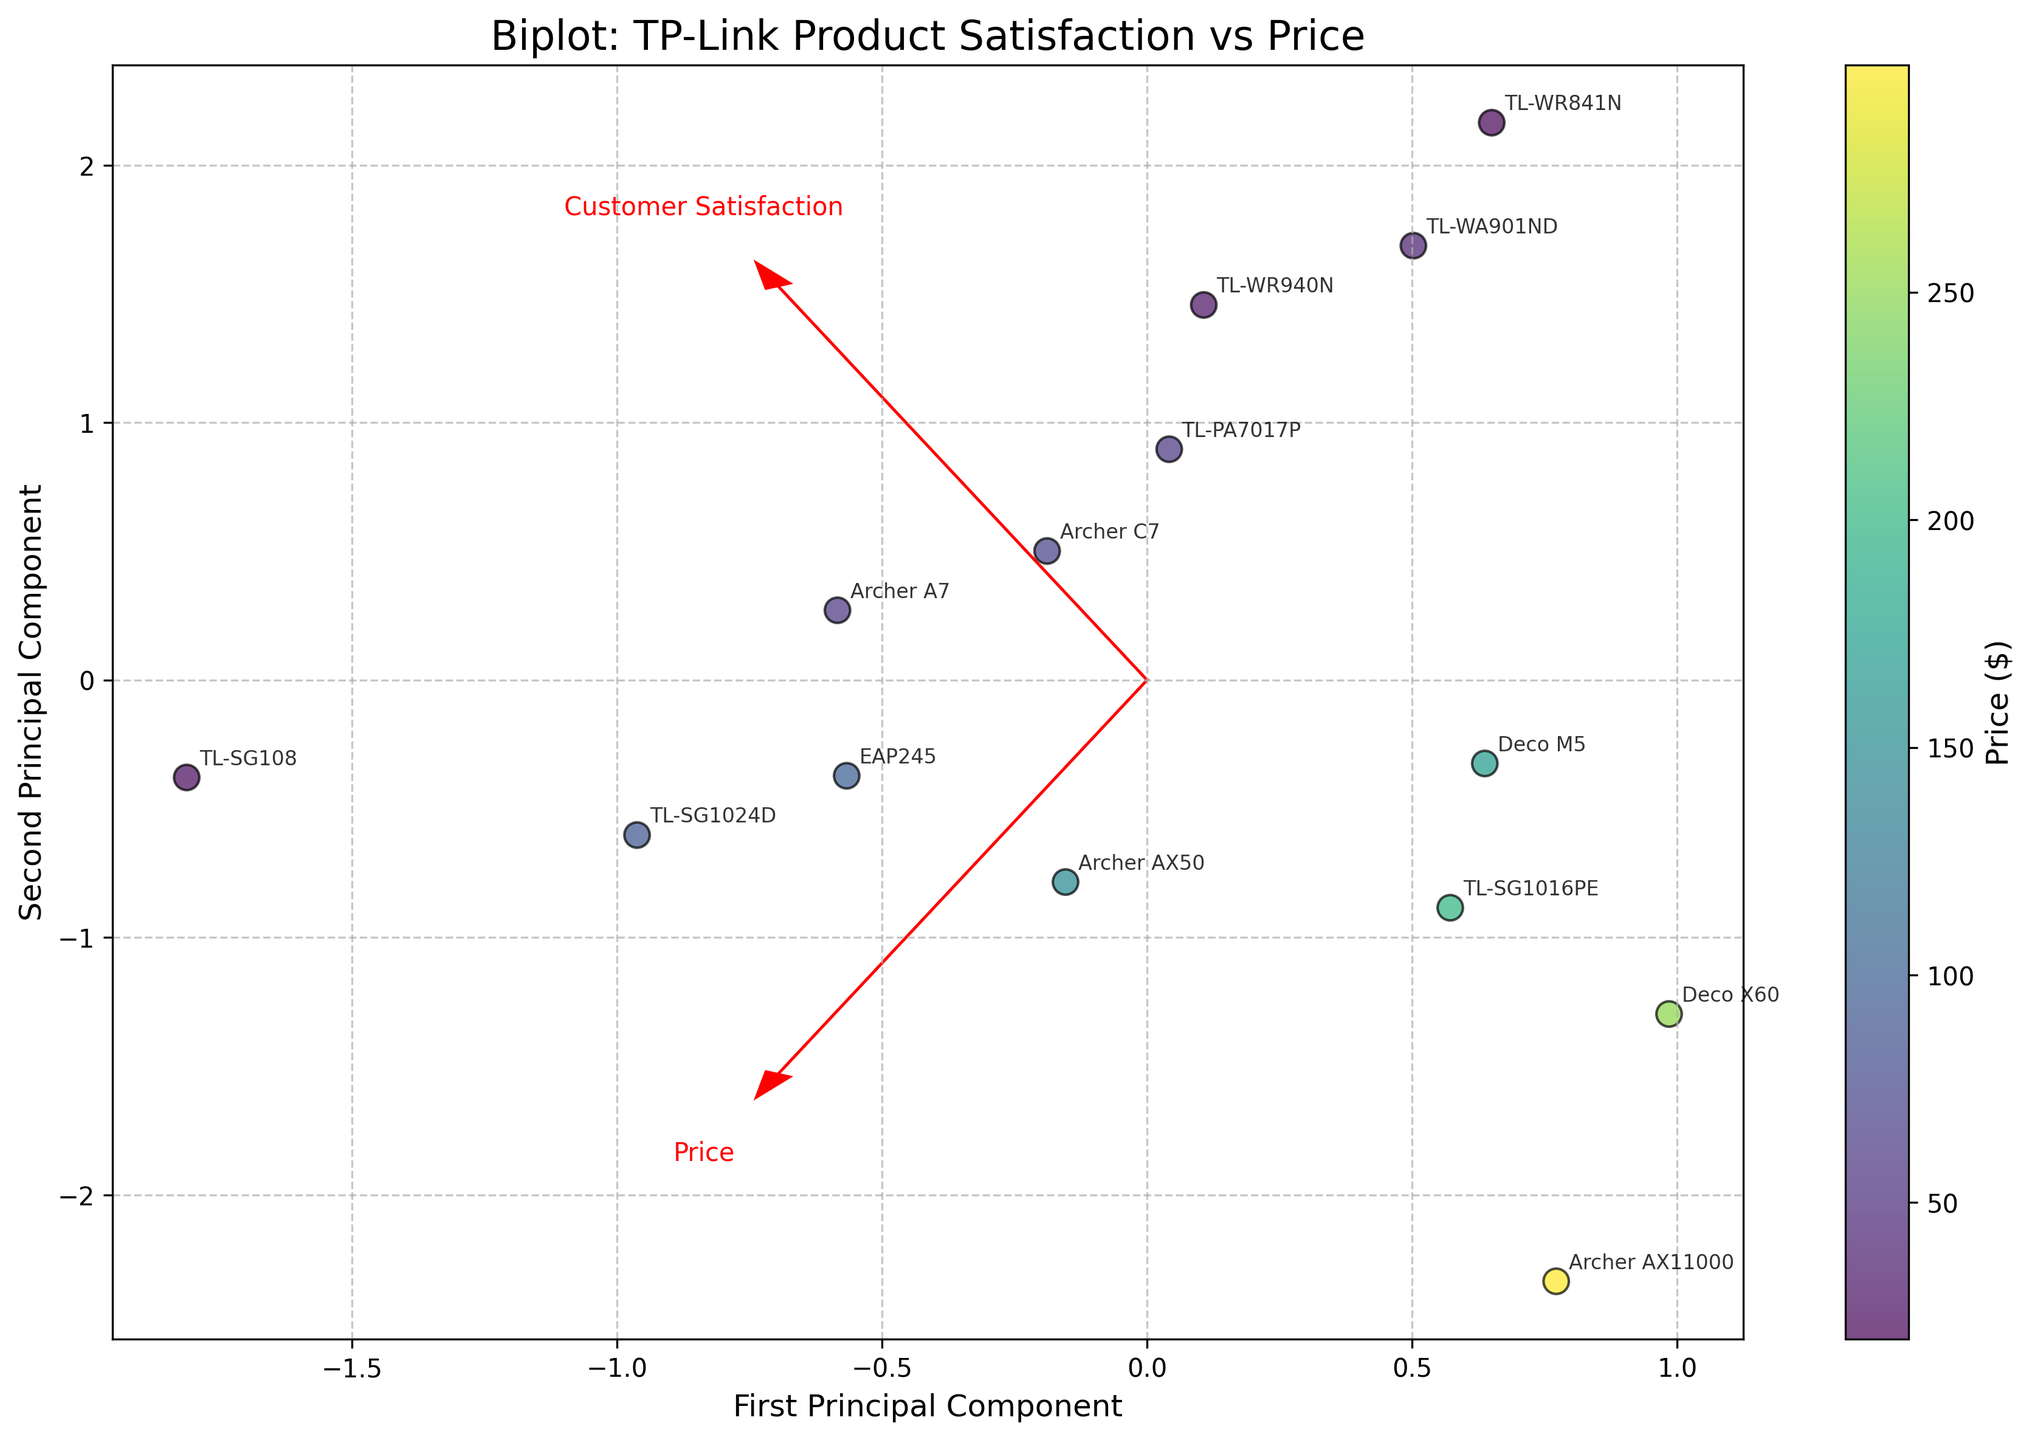What's the title of the plot? The title of the plot is displayed at the top of the figure. Simply read the title directly from the plot.
Answer: "Biplot: TP-Link Product Satisfaction vs Price" How many product data points are shown in the figure? Count the number of annotated points on the plot, as each represents a TP-Link product.
Answer: 14 Which product has the highest customer satisfaction rating? Identify the point corresponding to the product with the highest customer satisfaction axis value, based on the annotations.
Answer: TL-SG108 Which product is the most expensive? Find the point with the highest price gradient color, indicated by the colorbar.
Answer: Archer AX11000 Which product has the lowest price? Look for the point with the lowest price gradient color, according to the colorbar.
Answer: TL-WR841N Compare the customer satisfaction of TL-SG1024D and Archer A7. Which one is higher? Locate both products on the plot and compare their customer satisfaction values.
Answer: TL-SG1024D What is the relationship between customer satisfaction and price for the Archer AX11000? Look for the position of the Archer AX11000 on the plot and observe its coordinates relative to the customers' satisfaction and price vectors. The product is in the high customer satisfaction and high price quadrant.
Answer: High satisfaction, high price Which product lines have both high customer satisfaction and low price? Identify points that are in the high customer satisfaction vector projection and simultaneously in the low price gradient color.
Answer: TL-SG108, TL-WR940N Based on the biplot, what can you infer about the connection between customer satisfaction and price for TP-Link products in general? Observe the general trend in the plot. The arrow direction shows a positive correlation, meaning higher prices are generally correlated with higher customer satisfaction.
Answer: Higher price, higher satisfaction in general 